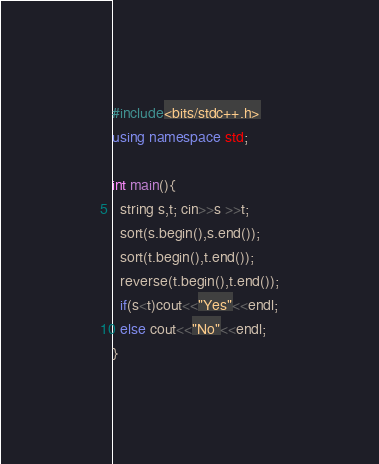Convert code to text. <code><loc_0><loc_0><loc_500><loc_500><_C++_>#include<bits/stdc++.h>
using namespace std;

int main(){
  string s,t; cin>>s >>t;
  sort(s.begin(),s.end());
  sort(t.begin(),t.end());
  reverse(t.begin(),t.end());
  if(s<t)cout<<"Yes"<<endl;
  else cout<<"No"<<endl;
}</code> 